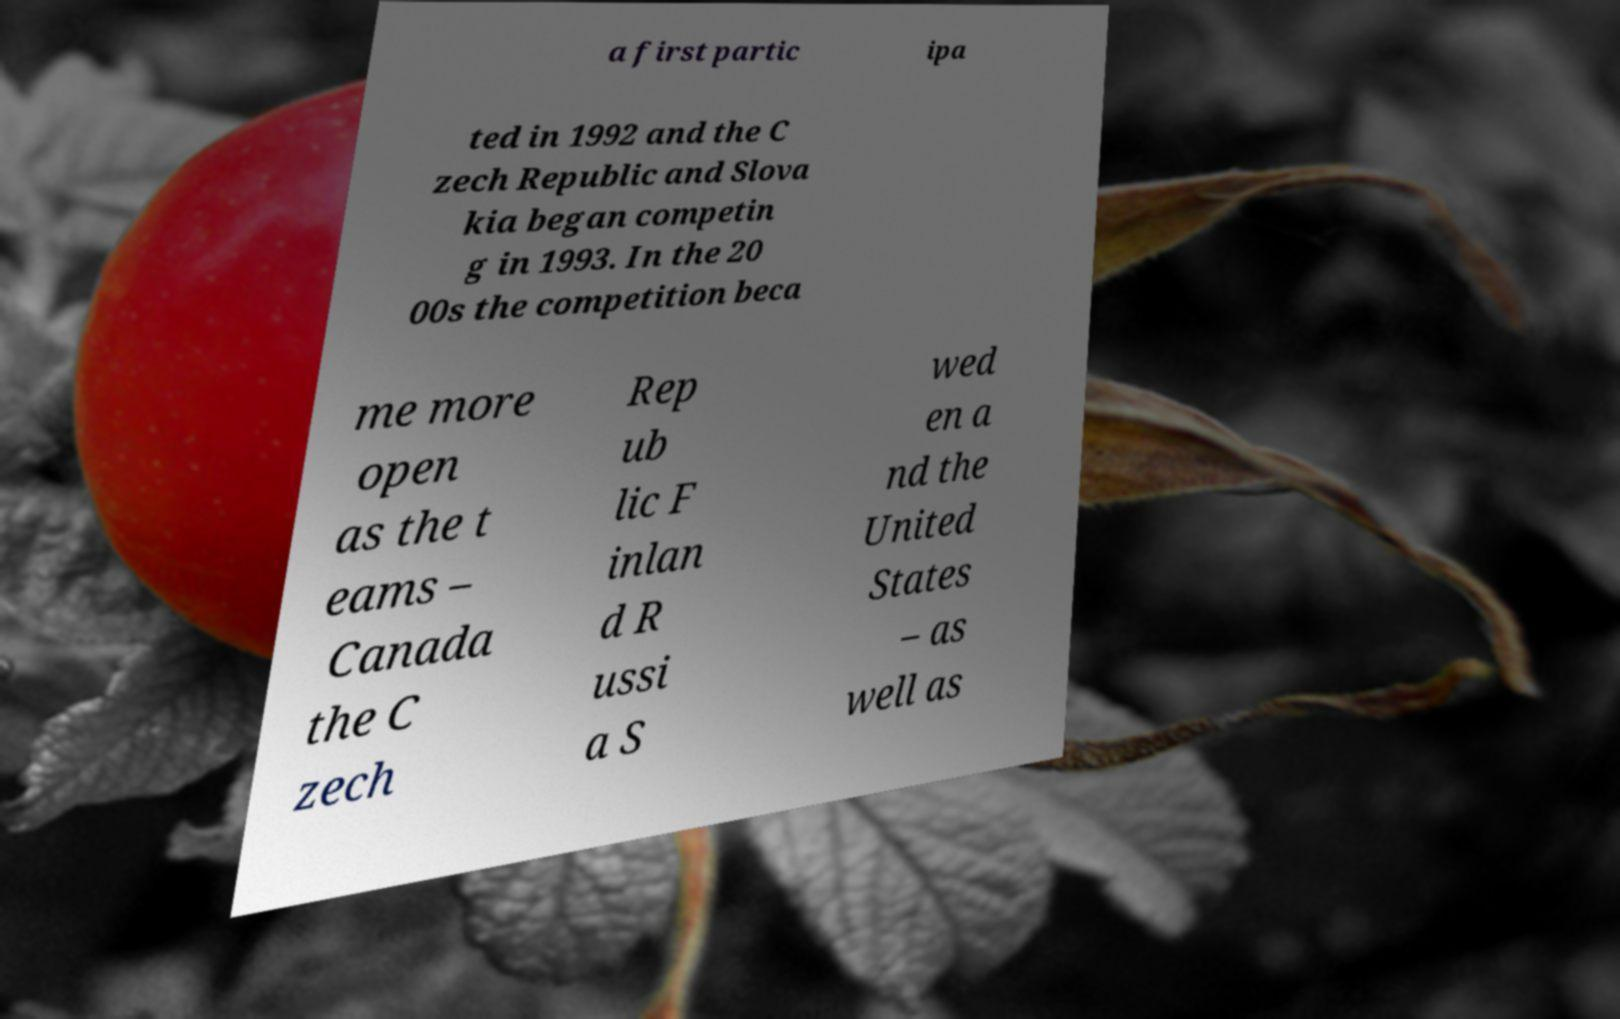Can you read and provide the text displayed in the image?This photo seems to have some interesting text. Can you extract and type it out for me? a first partic ipa ted in 1992 and the C zech Republic and Slova kia began competin g in 1993. In the 20 00s the competition beca me more open as the t eams – Canada the C zech Rep ub lic F inlan d R ussi a S wed en a nd the United States – as well as 